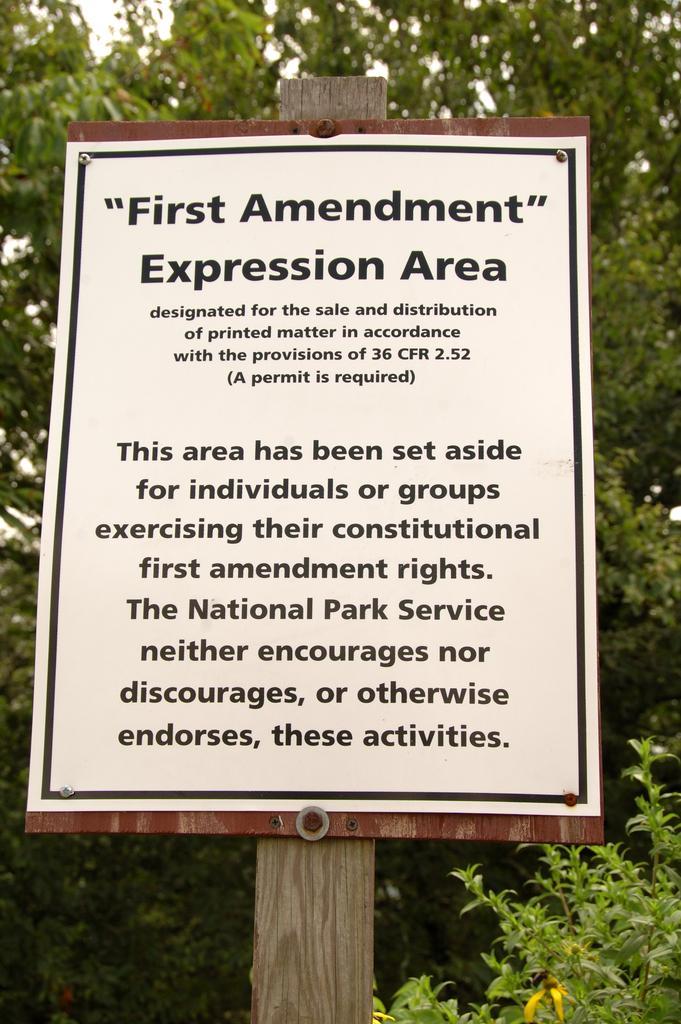In one or two sentences, can you explain what this image depicts? In the foreground of the picture there are board, pole and tree, on the board there is text. In the background there are trees. 